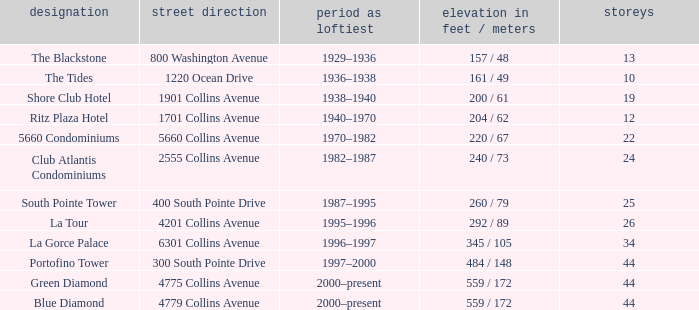What is the height of the Tides with less than 34 floors? 161 / 49. 